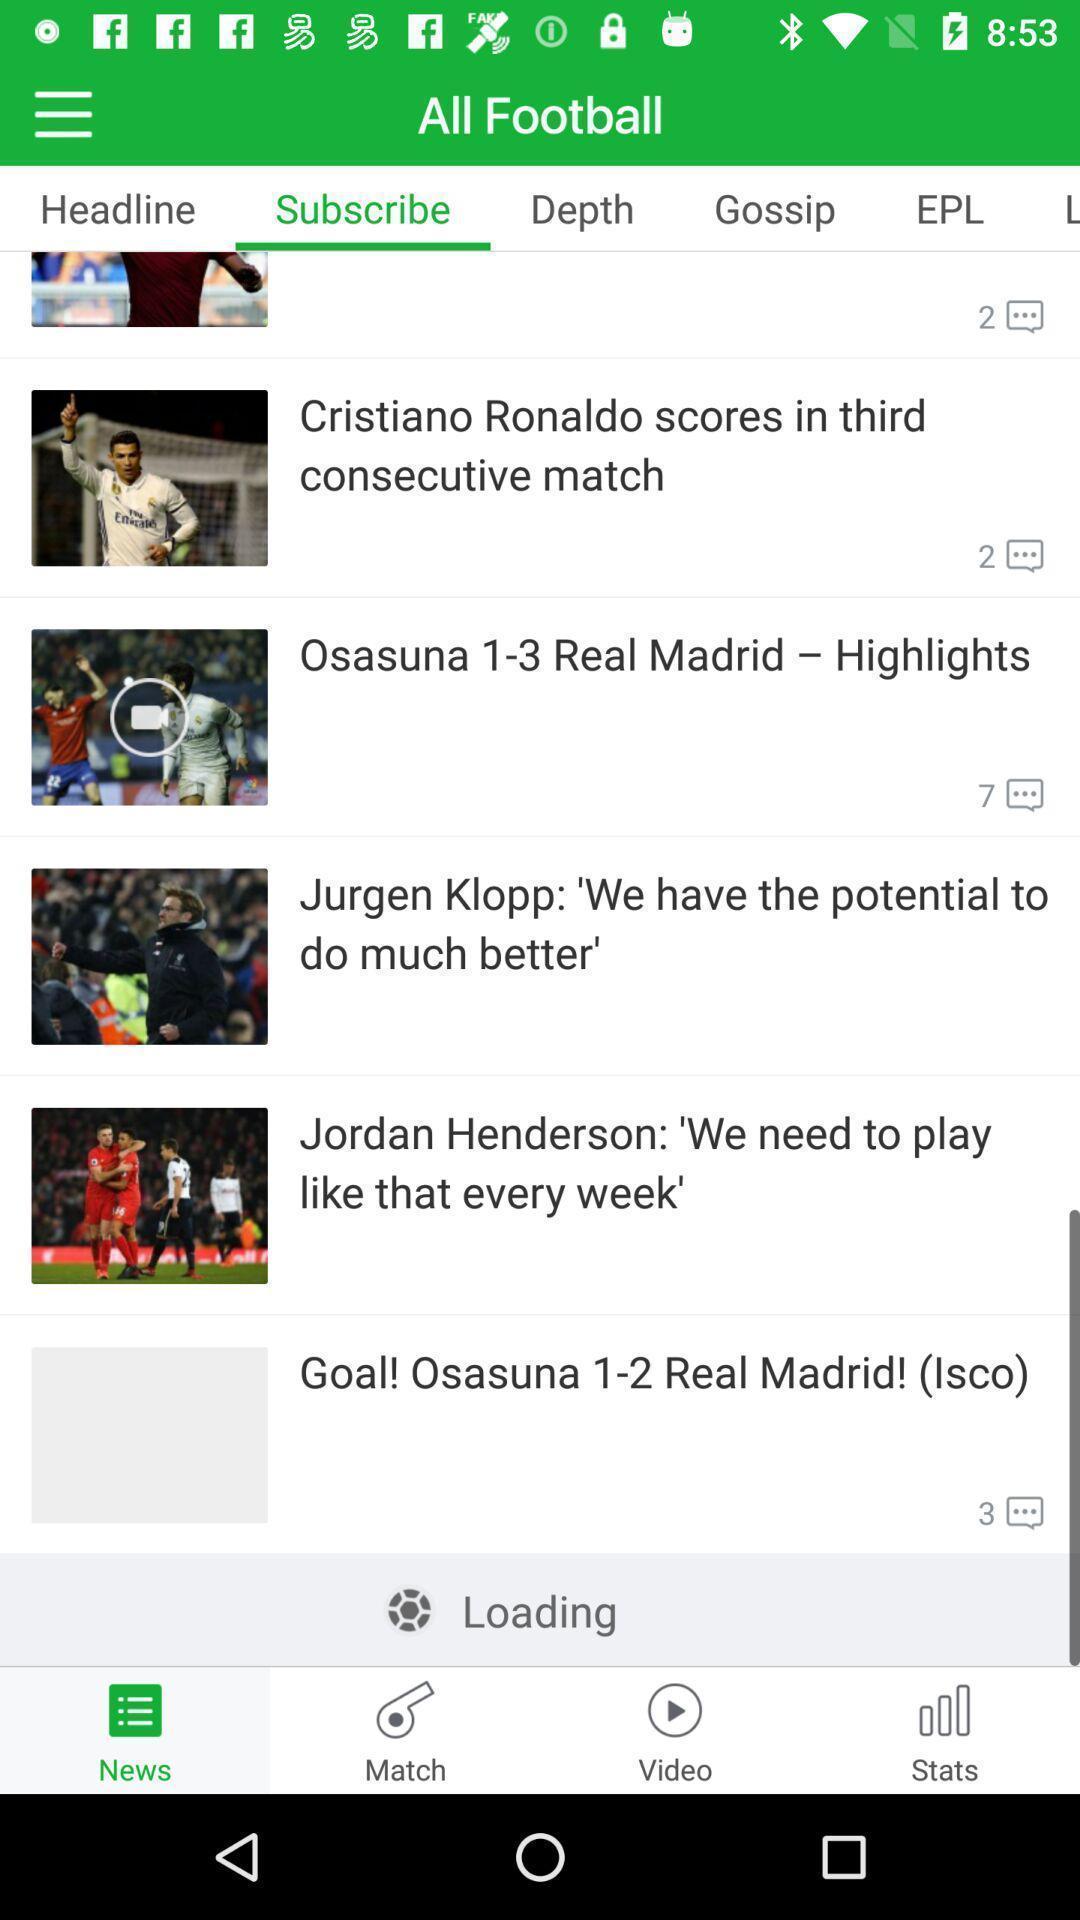What can you discern from this picture? Screen displaying the subscribe page. 